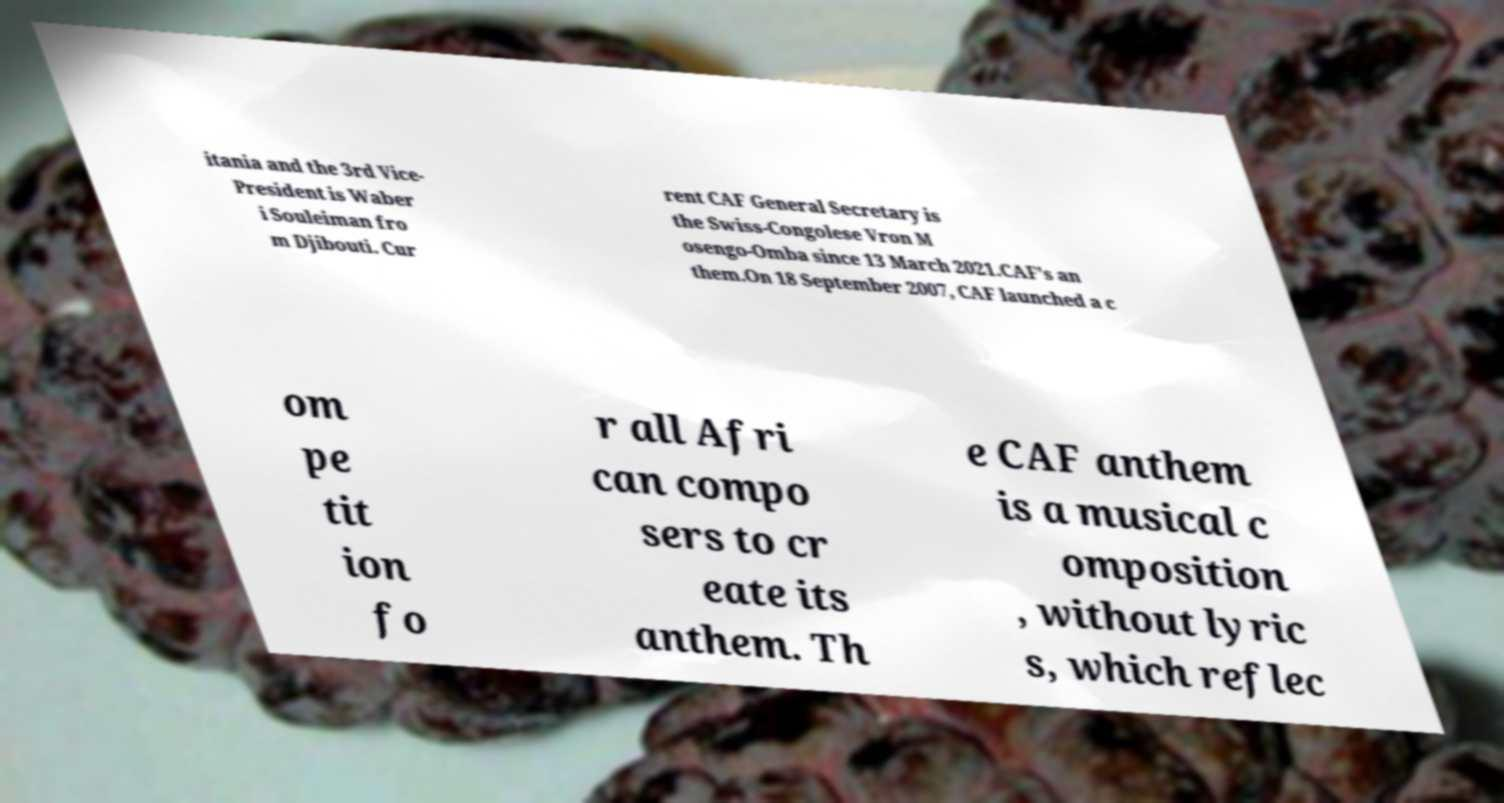Please read and relay the text visible in this image. What does it say? itania and the 3rd Vice- President is Waber i Souleiman fro m Djibouti. Cur rent CAF General Secretary is the Swiss-Congolese Vron M osengo-Omba since 13 March 2021.CAF's an them.On 18 September 2007, CAF launched a c om pe tit ion fo r all Afri can compo sers to cr eate its anthem. Th e CAF anthem is a musical c omposition , without lyric s, which reflec 